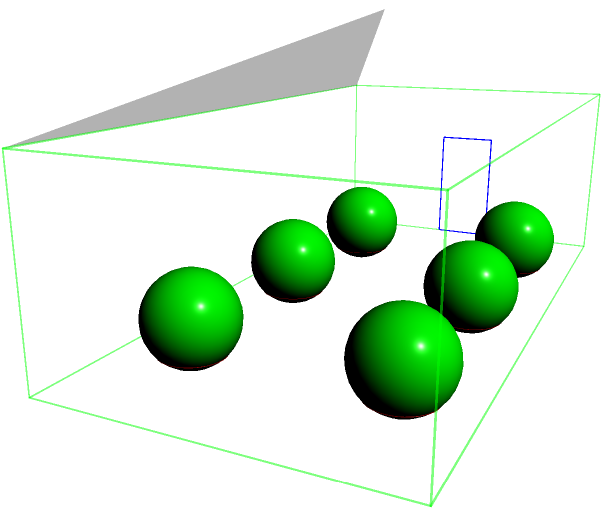Which of the following statements accurately describes the greenhouse layout when viewed from the front entrance?

A) The roof slopes upward from left to right
B) There are three rows of plants with two plants in each row
C) The door is located on the right side of the greenhouse
D) The greenhouse has a flat roof Let's analyze the greenhouse layout step-by-step:

1. Roof structure:
   The roof is clearly sloped, forming a triangular shape when viewed from the side. It rises from both the left and right sides to meet at a peak in the center.

2. Plant arrangement:
   There are two rows of plants visible, with three plants in each row. The plants are represented by brown cones (pots) with green spheres (foliage) on top.

3. Door position:
   The door is located on the front face of the greenhouse, which is the side closest to the viewer in this perspective. It's positioned slightly to the left of center.

4. Overall shape:
   The greenhouse has a rectangular base with a pitched roof, not a flat one.

Based on these observations, we can conclude that option B is the most accurate description of the greenhouse layout when viewed from the front entrance. There are indeed three columns of plants (when viewed from the front), with two plants in each column (or row when viewed from the side).
Answer: B 